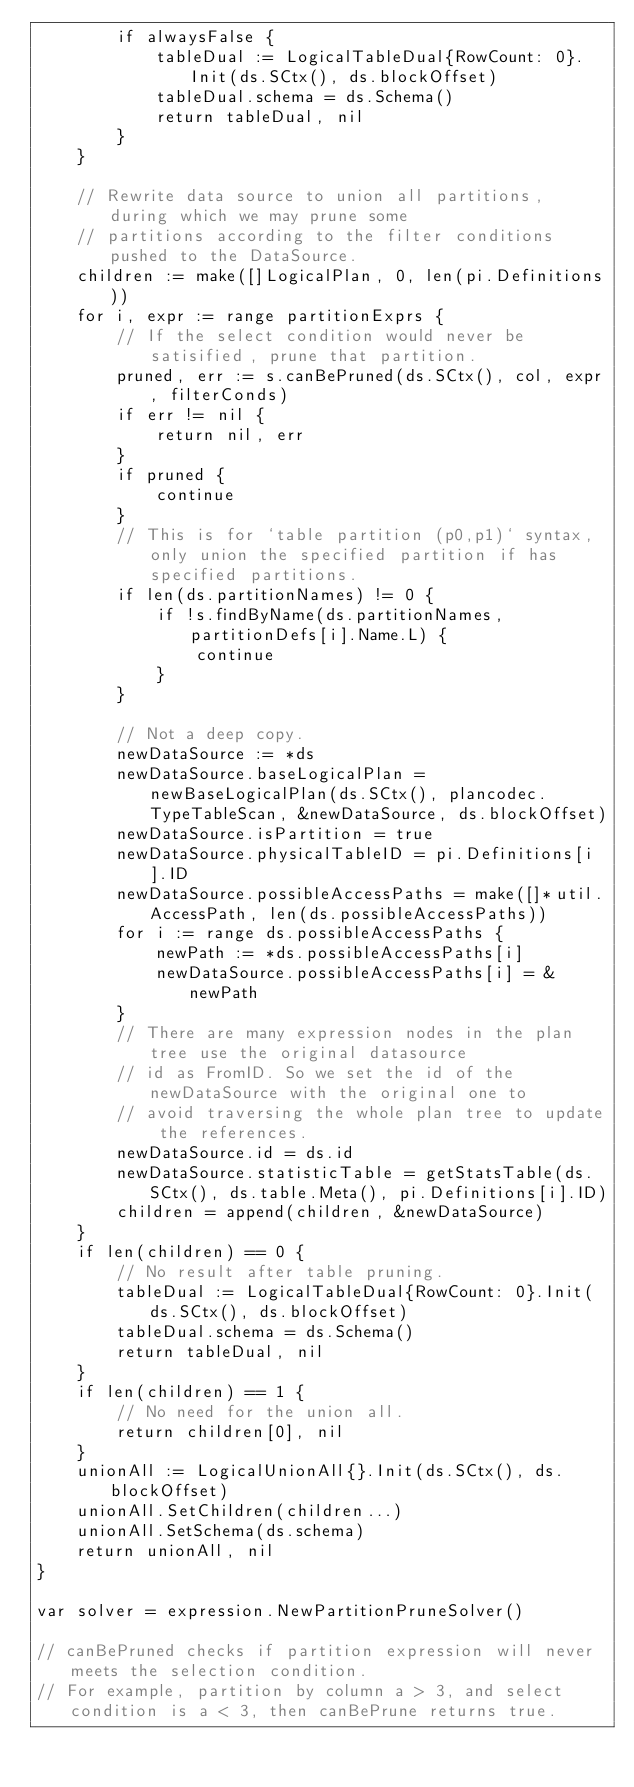Convert code to text. <code><loc_0><loc_0><loc_500><loc_500><_Go_>		if alwaysFalse {
			tableDual := LogicalTableDual{RowCount: 0}.Init(ds.SCtx(), ds.blockOffset)
			tableDual.schema = ds.Schema()
			return tableDual, nil
		}
	}

	// Rewrite data source to union all partitions, during which we may prune some
	// partitions according to the filter conditions pushed to the DataSource.
	children := make([]LogicalPlan, 0, len(pi.Definitions))
	for i, expr := range partitionExprs {
		// If the select condition would never be satisified, prune that partition.
		pruned, err := s.canBePruned(ds.SCtx(), col, expr, filterConds)
		if err != nil {
			return nil, err
		}
		if pruned {
			continue
		}
		// This is for `table partition (p0,p1)` syntax, only union the specified partition if has specified partitions.
		if len(ds.partitionNames) != 0 {
			if !s.findByName(ds.partitionNames, partitionDefs[i].Name.L) {
				continue
			}
		}

		// Not a deep copy.
		newDataSource := *ds
		newDataSource.baseLogicalPlan = newBaseLogicalPlan(ds.SCtx(), plancodec.TypeTableScan, &newDataSource, ds.blockOffset)
		newDataSource.isPartition = true
		newDataSource.physicalTableID = pi.Definitions[i].ID
		newDataSource.possibleAccessPaths = make([]*util.AccessPath, len(ds.possibleAccessPaths))
		for i := range ds.possibleAccessPaths {
			newPath := *ds.possibleAccessPaths[i]
			newDataSource.possibleAccessPaths[i] = &newPath
		}
		// There are many expression nodes in the plan tree use the original datasource
		// id as FromID. So we set the id of the newDataSource with the original one to
		// avoid traversing the whole plan tree to update the references.
		newDataSource.id = ds.id
		newDataSource.statisticTable = getStatsTable(ds.SCtx(), ds.table.Meta(), pi.Definitions[i].ID)
		children = append(children, &newDataSource)
	}
	if len(children) == 0 {
		// No result after table pruning.
		tableDual := LogicalTableDual{RowCount: 0}.Init(ds.SCtx(), ds.blockOffset)
		tableDual.schema = ds.Schema()
		return tableDual, nil
	}
	if len(children) == 1 {
		// No need for the union all.
		return children[0], nil
	}
	unionAll := LogicalUnionAll{}.Init(ds.SCtx(), ds.blockOffset)
	unionAll.SetChildren(children...)
	unionAll.SetSchema(ds.schema)
	return unionAll, nil
}

var solver = expression.NewPartitionPruneSolver()

// canBePruned checks if partition expression will never meets the selection condition.
// For example, partition by column a > 3, and select condition is a < 3, then canBePrune returns true.</code> 